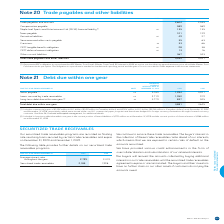According to Bce's financial document, What does the table show? Trade payables and other liabilities. The document states: "Note 20 Trade payables and other liabilities..." Also, What is the Trade payables and accruals for 2019? According to the financial document, 2,604. The relevant text states: "Trade payables and accruals 2,604 2,535..." Also, What are the years that the context makes reference to? The document shows two values: 2018 and 2019. From the document: "FOR THE YEAR ENDED DECEMBER 31 NOTE 2019 2018 FOR THE YEAR ENDED DECEMBER 31 NOTE 2019 2018..." Also, can you calculate: What is the total amount of taxes payable in 2018 and 2019? Based on the calculation: 101+129, the result is 230. This is based on the information: "Taxes payable 101 129 Taxes payable 101 129..." The key data points involved are: 101, 129. Also, can you calculate: What is the change in the amount of provisions in 2019? Based on the calculation: 33-66, the result is -33. This is based on the information: "Provisions 23 33 66 Provisions 23 33 66..." The key data points involved are: 66. Also, can you calculate: What is the percentage change in the amount of CRTC tangible benefits obligation in 2019? To answer this question, I need to perform calculations using the financial data. The calculation is: (28-38)/38, which equals -26.32 (percentage). This is based on the information: "CRTC tangible benefits obligation 26 28 38 CRTC tangible benefits obligation 26 28 38..." The key data points involved are: 28, 38. 